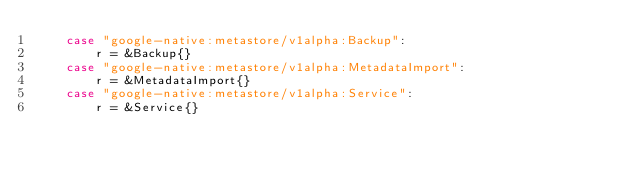Convert code to text. <code><loc_0><loc_0><loc_500><loc_500><_Go_>	case "google-native:metastore/v1alpha:Backup":
		r = &Backup{}
	case "google-native:metastore/v1alpha:MetadataImport":
		r = &MetadataImport{}
	case "google-native:metastore/v1alpha:Service":
		r = &Service{}</code> 